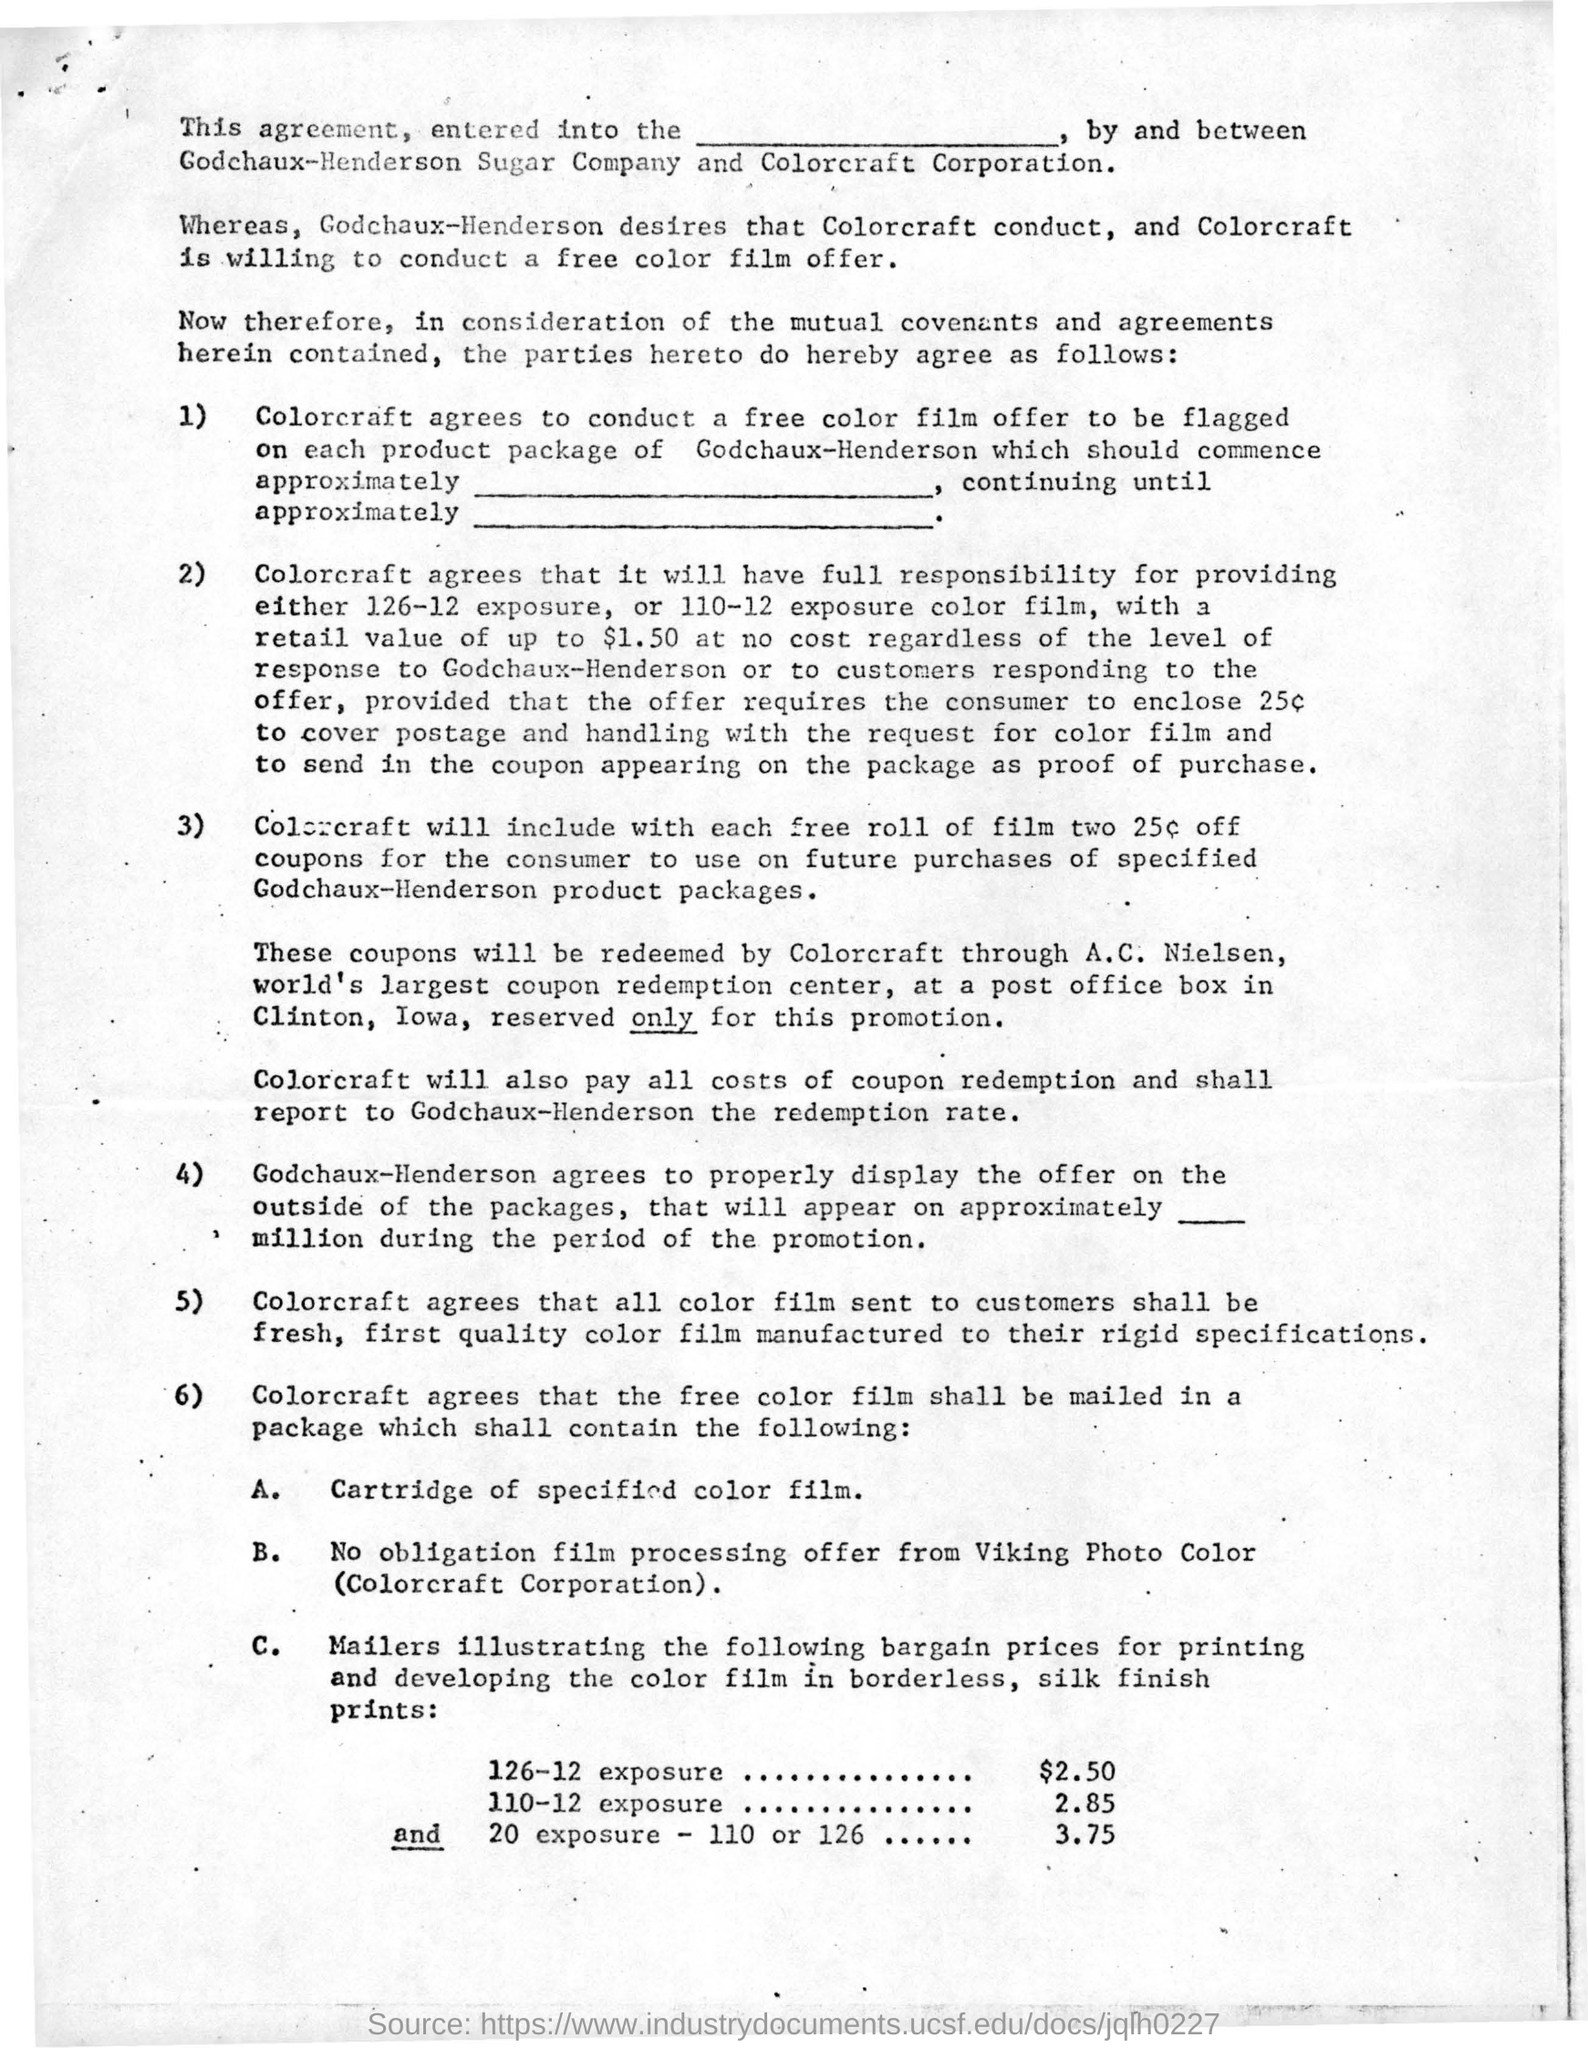Through whom will colorcraft redeem these coupons?
Provide a succinct answer. A.C. Nielsen, world's largest coupon redemption center. 